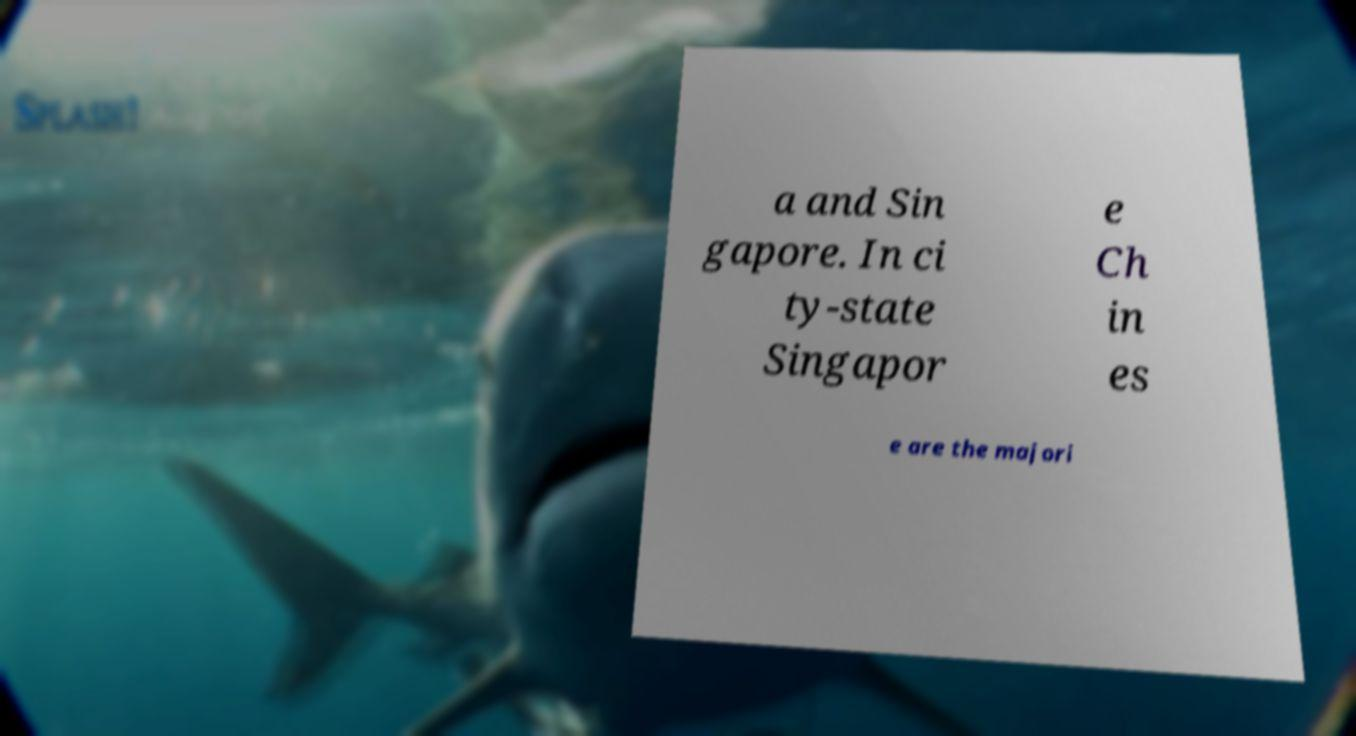What messages or text are displayed in this image? I need them in a readable, typed format. a and Sin gapore. In ci ty-state Singapor e Ch in es e are the majori 